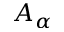Convert formula to latex. <formula><loc_0><loc_0><loc_500><loc_500>A _ { \alpha }</formula> 